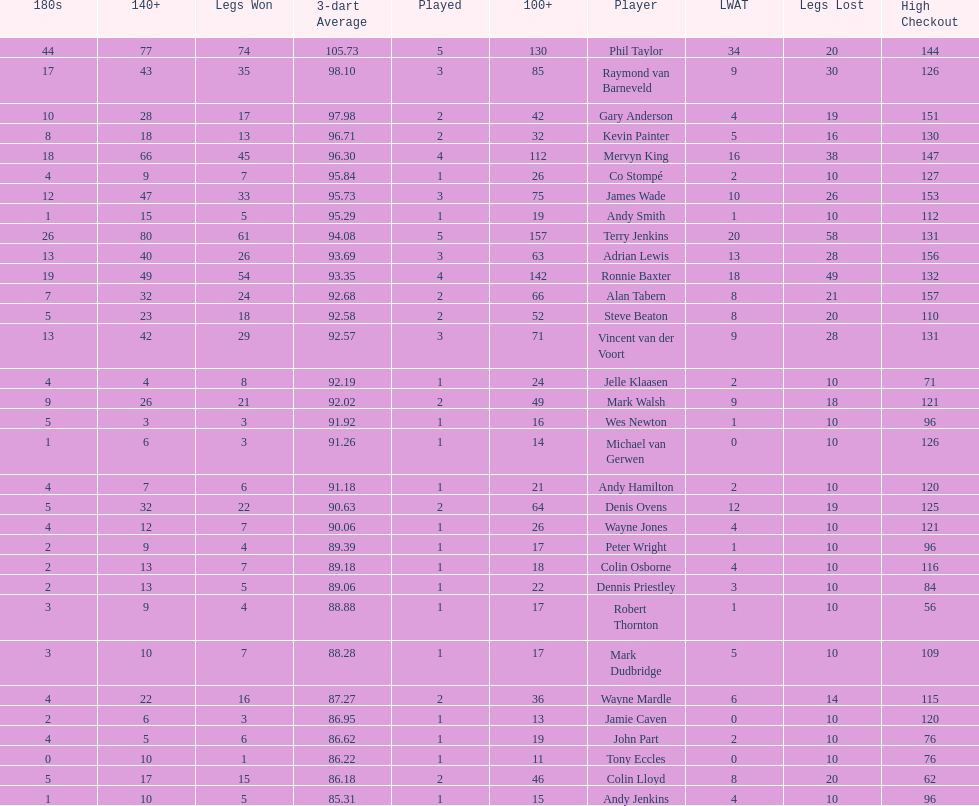Who won the highest number of legs in the 2009 world matchplay? Phil Taylor. 